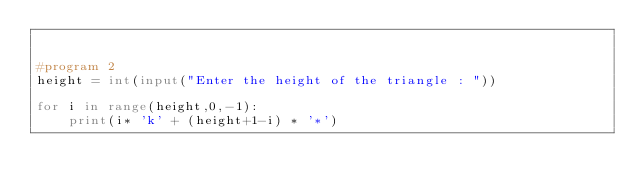Convert code to text. <code><loc_0><loc_0><loc_500><loc_500><_Python_>    
    
#program 2
height = int(input("Enter the height of the triangle : "))

for i in range(height,0,-1):
    print(i* 'k' + (height+1-i) * '*')
</code> 